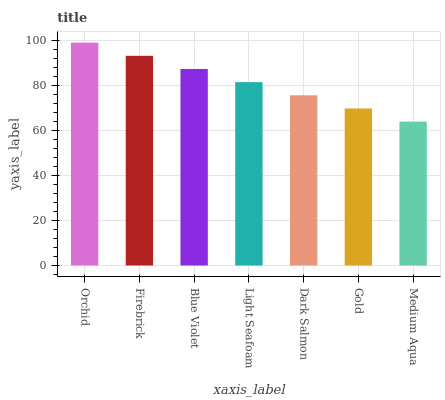Is Firebrick the minimum?
Answer yes or no. No. Is Firebrick the maximum?
Answer yes or no. No. Is Orchid greater than Firebrick?
Answer yes or no. Yes. Is Firebrick less than Orchid?
Answer yes or no. Yes. Is Firebrick greater than Orchid?
Answer yes or no. No. Is Orchid less than Firebrick?
Answer yes or no. No. Is Light Seafoam the high median?
Answer yes or no. Yes. Is Light Seafoam the low median?
Answer yes or no. Yes. Is Blue Violet the high median?
Answer yes or no. No. Is Firebrick the low median?
Answer yes or no. No. 